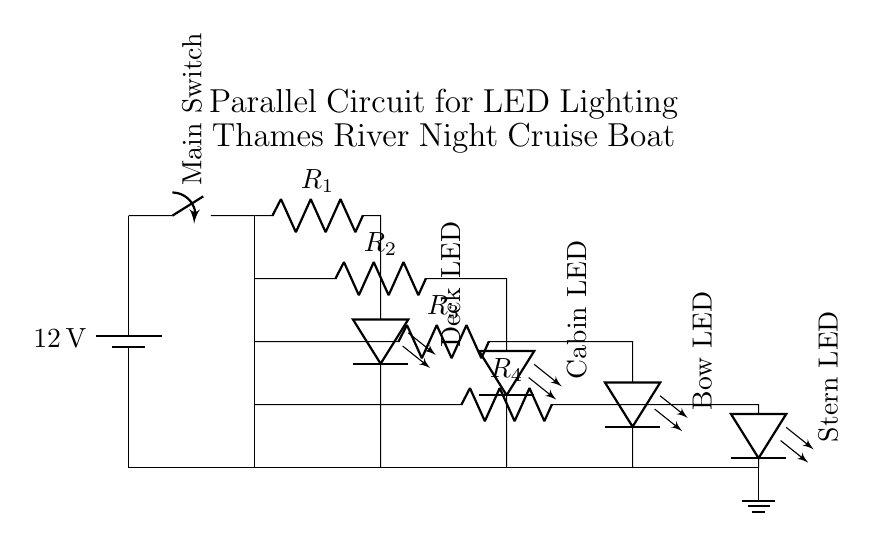What is the voltage of the battery? The battery in the circuit is labeled as providing twelve volts, which indicates the potential difference available for the circuit operation.
Answer: twelve volts What type of circuit is this? The diagram clearly shows that multiple components are connected in parallel, indicated by separate branches for each LED and resistor combination originating from a common voltage source.
Answer: parallel How many LED lights are controlled in this circuit? The circuit diagram depicts four separate LED lights, each connected in parallel. This can be counted directly from the branches leading to each LED.
Answer: four What is the purpose of the resistors in this circuit? Resistors are in place to limit the amount of current flowing to each LED, preventing them from drawing too much current which could result in damage. Each resistor is labeled, showing it is paired with its corresponding LED.
Answer: limit current What is the connection path for the 'Deck LED'? The path for the Deck LED starts from the battery, through the main switch, down to R1, and finally to the Deck LED. This follows the parallel configuration towards the LED, ensuring it receives the same voltage as the battery.
Answer: battery to switch to R1 to Deck LED Which component is controlling the entire circuit? The main switch is the component that controls the operation of the entire circuit. It allows or interrupts current flow to all parallel branches connected downstream.
Answer: main switch 